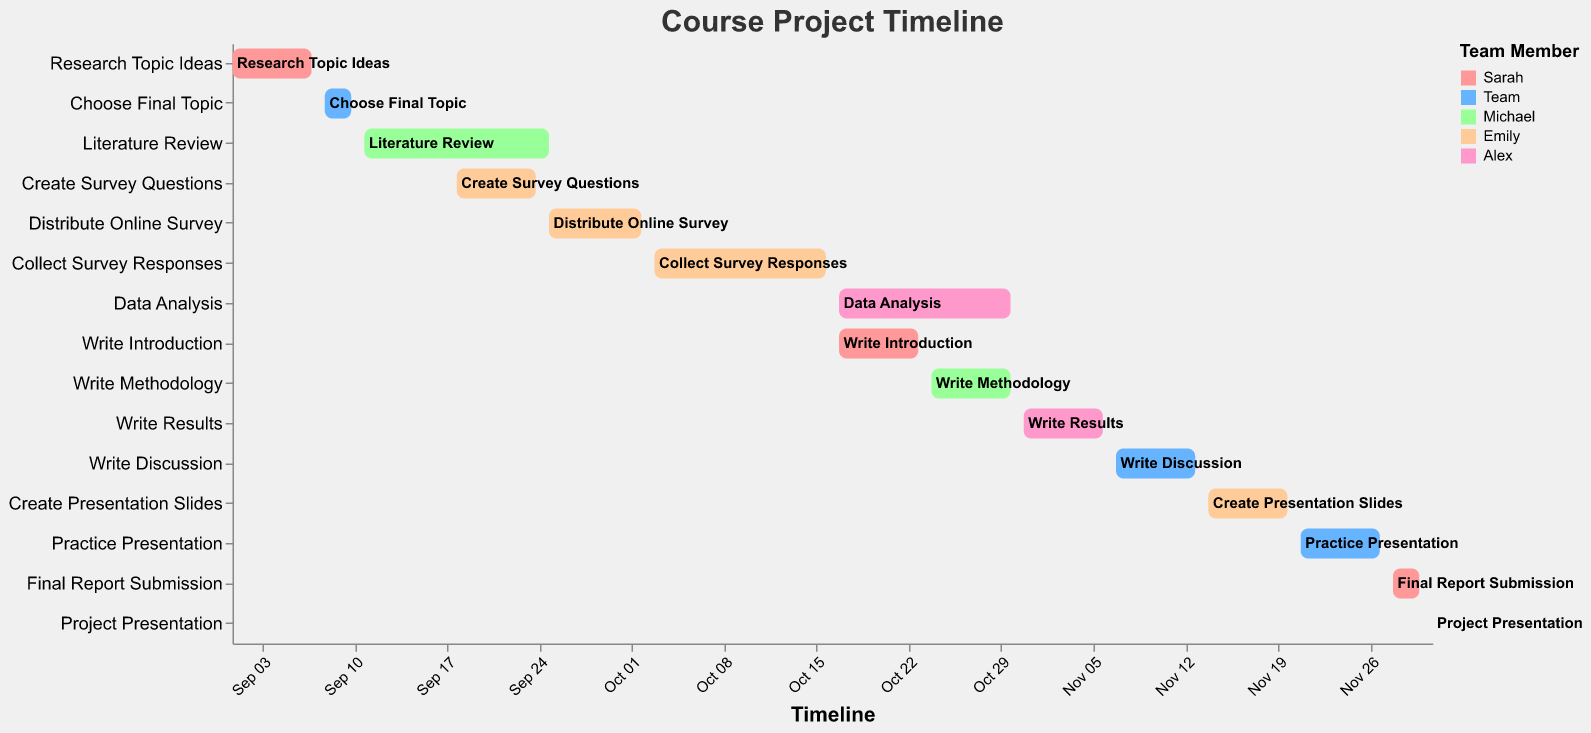what is the title of the figure? The title is displayed at the top of the figure, reading "Course Project Timeline."
Answer: Course Project Timeline who is responsible for the task "create survey questions"? By referring to the task assigned to "Create Survey Questions," we see that the assignee is Emily.
Answer: Emily how long does the literature review task last? The duration of the "Literature Review" task is listed directly in the figure and is 15 days.
Answer: 15 days what is the shortest task in the timeline? By scanning through the durations of all the tasks, the "Project Presentation" is the shortest as it lasts only 1 day.
Answer: Project Presentation which team member is assigned the most tasks? By counting the number of tasks each team member is assigned, Emily has the most tasks with a total of four.
Answer: Emily how many tasks occur simultaneously with the task "collect survey responses"? The task "Collect Survey Responses" overlaps with one other task, "Data Analysis," both occurring from October 17 to October 23.
Answer: One task when does the task "data analysis" start and end? The task "Data Analysis" starts on October 17 and ends on October 30, as shown in the figure.
Answer: October 17 to October 30 do any tasks overlap with "write introduction"? if so, which ones? The "Write Introduction" task overlaps with "Data Analysis" from October 17 to October 23.
Answer: Data Analysis how many tasks are there in total? By counting all the bars (tasks) in the figure, there are 15 tasks in total.
Answer: 15 tasks who completes the final report submission? The "Final Report Submission" task is assigned to Sarah, as indicated in the figure.
Answer: Sarah 